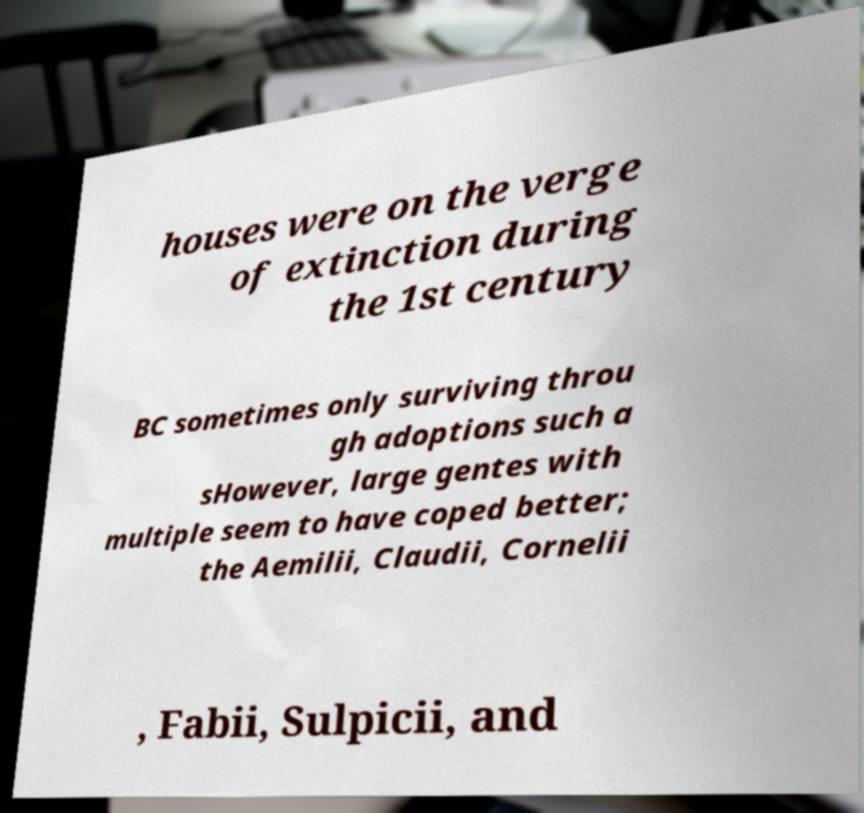I need the written content from this picture converted into text. Can you do that? houses were on the verge of extinction during the 1st century BC sometimes only surviving throu gh adoptions such a sHowever, large gentes with multiple seem to have coped better; the Aemilii, Claudii, Cornelii , Fabii, Sulpicii, and 